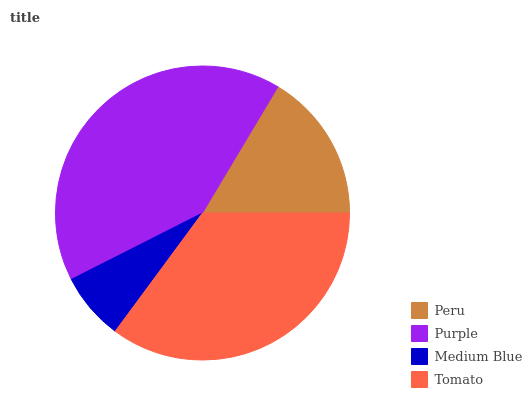Is Medium Blue the minimum?
Answer yes or no. Yes. Is Purple the maximum?
Answer yes or no. Yes. Is Purple the minimum?
Answer yes or no. No. Is Medium Blue the maximum?
Answer yes or no. No. Is Purple greater than Medium Blue?
Answer yes or no. Yes. Is Medium Blue less than Purple?
Answer yes or no. Yes. Is Medium Blue greater than Purple?
Answer yes or no. No. Is Purple less than Medium Blue?
Answer yes or no. No. Is Tomato the high median?
Answer yes or no. Yes. Is Peru the low median?
Answer yes or no. Yes. Is Purple the high median?
Answer yes or no. No. Is Tomato the low median?
Answer yes or no. No. 